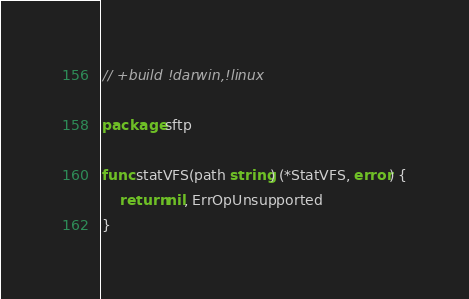<code> <loc_0><loc_0><loc_500><loc_500><_Go_>// +build !darwin,!linux

package sftp

func statVFS(path string) (*StatVFS, error) {
	return nil, ErrOpUnsupported
}
</code> 